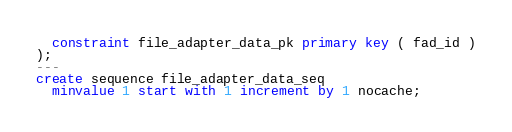<code> <loc_0><loc_0><loc_500><loc_500><_SQL_>  constraint file_adapter_data_pk primary key ( fad_id )
);
---
create sequence file_adapter_data_seq 
  minvalue 1 start with 1 increment by 1 nocache;</code> 